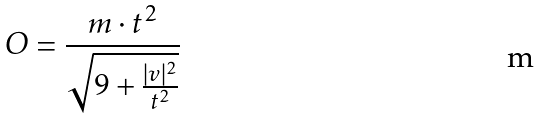Convert formula to latex. <formula><loc_0><loc_0><loc_500><loc_500>O = \frac { m \cdot t ^ { 2 } } { \sqrt { 9 + \frac { | v | ^ { 2 } } { t ^ { 2 } } } }</formula> 